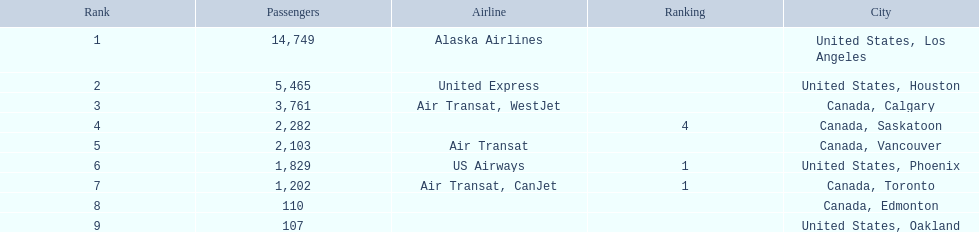What were all the passenger totals? 14,749, 5,465, 3,761, 2,282, 2,103, 1,829, 1,202, 110, 107. Which of these were to los angeles? 14,749. What other destination combined with this is closest to 19,000? Canada, Calgary. 